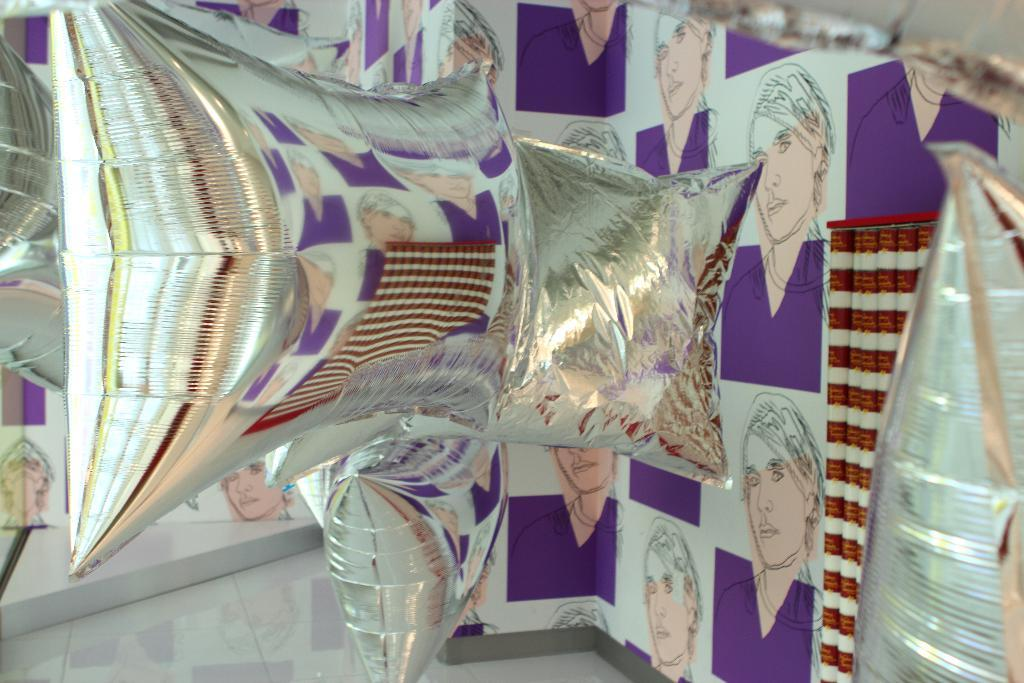What type of objects can be seen in the image? There are pillows in the image. What can be seen in the background of the image? There is an object in the background that resembles a board. What is depicted on the board? The board has images of a person on it. What is visible at the bottom of the image? The floor is visible at the bottom of the image. What type of sports equipment can be seen in the image? There is no sports equipment present in the image. Can you tell me how many basketballs are stored in the drawer in the image? There is no drawer or basketballs present in the image. 